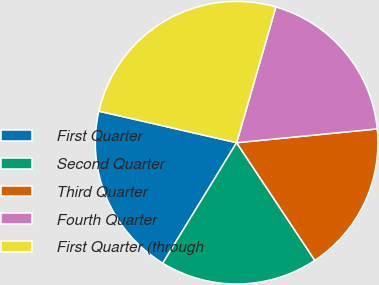<chart> <loc_0><loc_0><loc_500><loc_500><pie_chart><fcel>First Quarter<fcel>Second Quarter<fcel>Third Quarter<fcel>Fourth Quarter<fcel>First Quarter (through<nl><fcel>19.83%<fcel>18.09%<fcel>17.22%<fcel>18.96%<fcel>25.9%<nl></chart> 